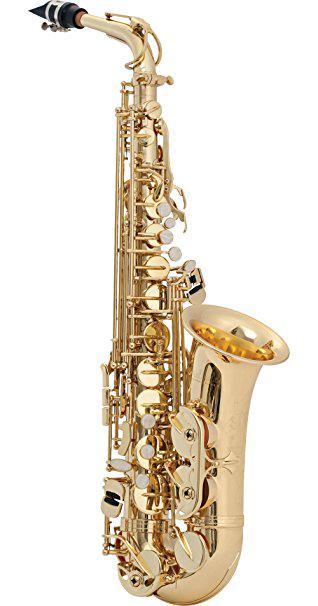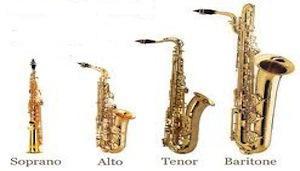The first image is the image on the left, the second image is the image on the right. For the images displayed, is the sentence "Neither of the images in the pair show more than three saxophones." factually correct? Answer yes or no. No. The first image is the image on the left, the second image is the image on the right. Given the left and right images, does the statement "There is a soprano saxophone labeled." hold true? Answer yes or no. Yes. 